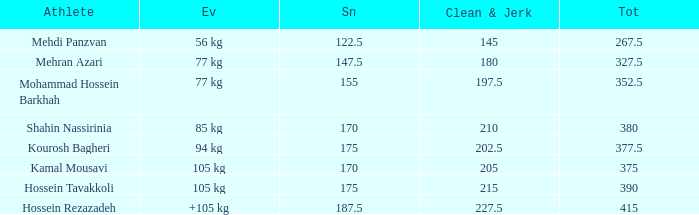Can you parse all the data within this table? {'header': ['Athlete', 'Ev', 'Sn', 'Clean & Jerk', 'Tot'], 'rows': [['Mehdi Panzvan', '56 kg', '122.5', '145', '267.5'], ['Mehran Azari', '77 kg', '147.5', '180', '327.5'], ['Mohammad Hossein Barkhah', '77 kg', '155', '197.5', '352.5'], ['Shahin Nassirinia', '85 kg', '170', '210', '380'], ['Kourosh Bagheri', '94 kg', '175', '202.5', '377.5'], ['Kamal Mousavi', '105 kg', '170', '205', '375'], ['Hossein Tavakkoli', '105 kg', '175', '215', '390'], ['Hossein Rezazadeh', '+105 kg', '187.5', '227.5', '415']]} How many snatches were there with a total of 267.5? 0.0. 